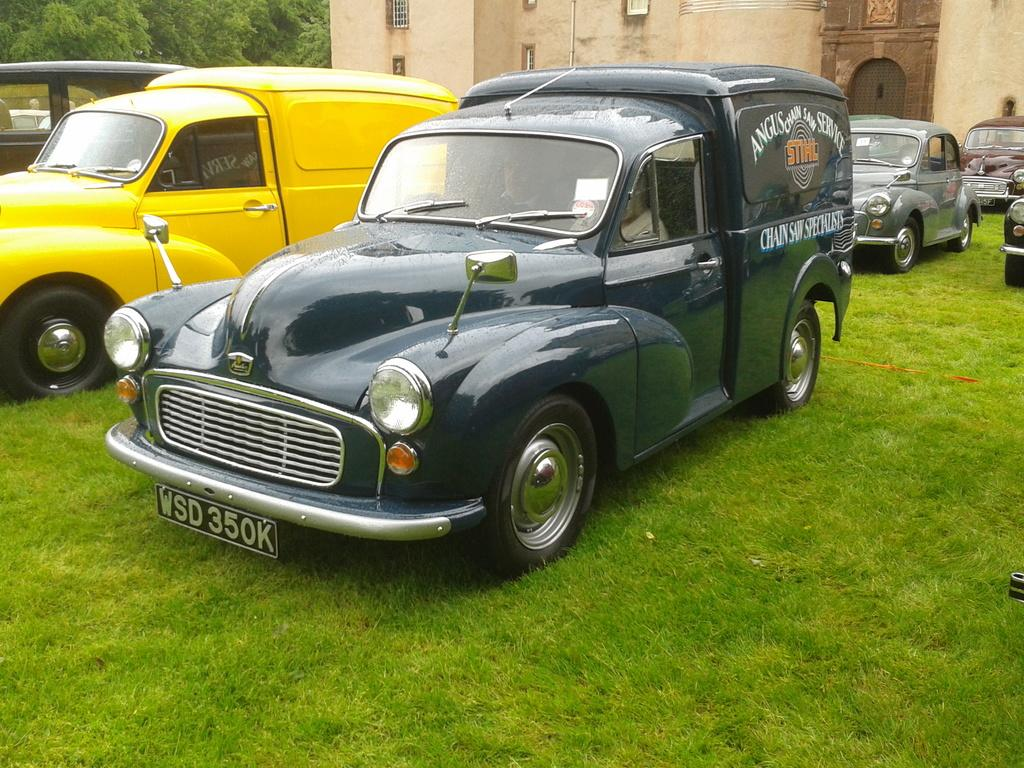What is the location of the vehicles in the image? The vehicles are on the grass in the image. Can you describe the appearance of the vehicles? The vehicles are in different colors. What can be seen in the background of the image? There is a building with windows and many trees in the background. What type of joke is the tiger telling near the door in the image? There is no tiger or door present in the image, so it is not possible to answer that question. 